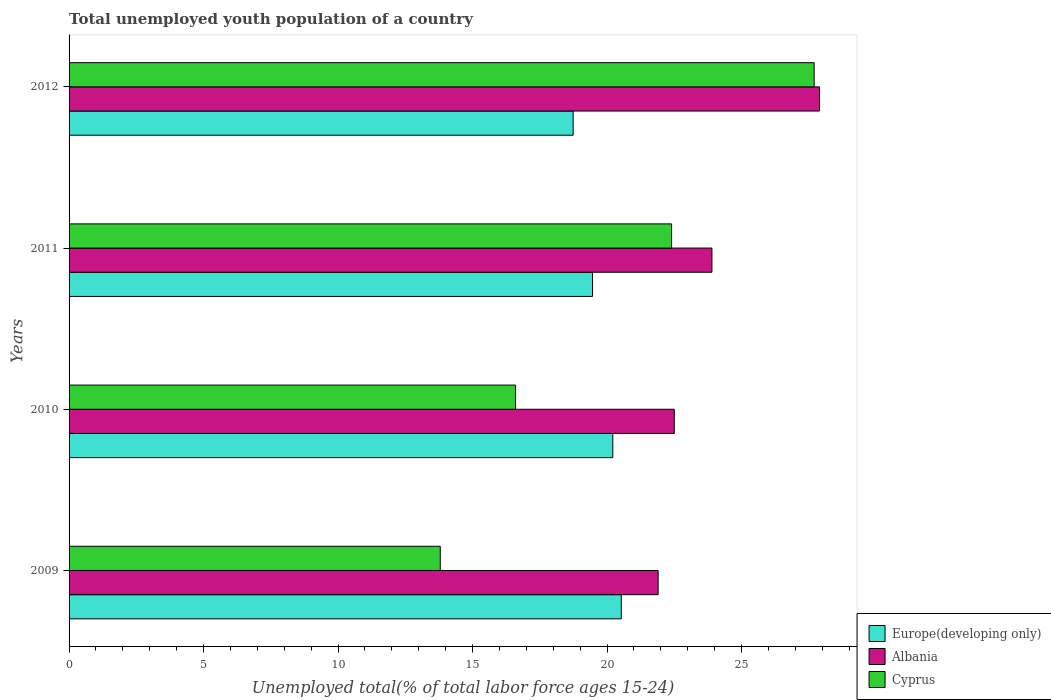How many different coloured bars are there?
Give a very brief answer. 3. How many groups of bars are there?
Your answer should be very brief. 4. How many bars are there on the 4th tick from the top?
Provide a short and direct response. 3. In how many cases, is the number of bars for a given year not equal to the number of legend labels?
Give a very brief answer. 0. What is the percentage of total unemployed youth population of a country in Cyprus in 2009?
Offer a terse response. 13.8. Across all years, what is the maximum percentage of total unemployed youth population of a country in Europe(developing only)?
Offer a very short reply. 20.53. Across all years, what is the minimum percentage of total unemployed youth population of a country in Cyprus?
Ensure brevity in your answer.  13.8. In which year was the percentage of total unemployed youth population of a country in Europe(developing only) maximum?
Provide a short and direct response. 2009. What is the total percentage of total unemployed youth population of a country in Europe(developing only) in the graph?
Provide a short and direct response. 78.95. What is the difference between the percentage of total unemployed youth population of a country in Albania in 2009 and that in 2010?
Your answer should be compact. -0.6. What is the difference between the percentage of total unemployed youth population of a country in Albania in 2010 and the percentage of total unemployed youth population of a country in Cyprus in 2009?
Offer a terse response. 8.7. What is the average percentage of total unemployed youth population of a country in Europe(developing only) per year?
Make the answer very short. 19.74. In the year 2009, what is the difference between the percentage of total unemployed youth population of a country in Albania and percentage of total unemployed youth population of a country in Europe(developing only)?
Offer a terse response. 1.37. What is the ratio of the percentage of total unemployed youth population of a country in Cyprus in 2010 to that in 2011?
Make the answer very short. 0.74. Is the percentage of total unemployed youth population of a country in Cyprus in 2009 less than that in 2011?
Your answer should be very brief. Yes. What is the difference between the highest and the second highest percentage of total unemployed youth population of a country in Cyprus?
Your response must be concise. 5.3. What is the difference between the highest and the lowest percentage of total unemployed youth population of a country in Europe(developing only)?
Your response must be concise. 1.79. Is the sum of the percentage of total unemployed youth population of a country in Albania in 2010 and 2012 greater than the maximum percentage of total unemployed youth population of a country in Cyprus across all years?
Give a very brief answer. Yes. What does the 1st bar from the top in 2012 represents?
Ensure brevity in your answer.  Cyprus. What does the 1st bar from the bottom in 2011 represents?
Offer a terse response. Europe(developing only). Is it the case that in every year, the sum of the percentage of total unemployed youth population of a country in Cyprus and percentage of total unemployed youth population of a country in Albania is greater than the percentage of total unemployed youth population of a country in Europe(developing only)?
Provide a short and direct response. Yes. How many bars are there?
Provide a succinct answer. 12. Are all the bars in the graph horizontal?
Offer a very short reply. Yes. How many years are there in the graph?
Your response must be concise. 4. What is the difference between two consecutive major ticks on the X-axis?
Provide a short and direct response. 5. Are the values on the major ticks of X-axis written in scientific E-notation?
Provide a short and direct response. No. Does the graph contain any zero values?
Ensure brevity in your answer.  No. Does the graph contain grids?
Make the answer very short. No. Where does the legend appear in the graph?
Offer a very short reply. Bottom right. How are the legend labels stacked?
Make the answer very short. Vertical. What is the title of the graph?
Give a very brief answer. Total unemployed youth population of a country. What is the label or title of the X-axis?
Give a very brief answer. Unemployed total(% of total labor force ages 15-24). What is the Unemployed total(% of total labor force ages 15-24) in Europe(developing only) in 2009?
Your answer should be very brief. 20.53. What is the Unemployed total(% of total labor force ages 15-24) in Albania in 2009?
Make the answer very short. 21.9. What is the Unemployed total(% of total labor force ages 15-24) in Cyprus in 2009?
Provide a short and direct response. 13.8. What is the Unemployed total(% of total labor force ages 15-24) in Europe(developing only) in 2010?
Provide a short and direct response. 20.21. What is the Unemployed total(% of total labor force ages 15-24) of Albania in 2010?
Provide a succinct answer. 22.5. What is the Unemployed total(% of total labor force ages 15-24) of Cyprus in 2010?
Offer a terse response. 16.6. What is the Unemployed total(% of total labor force ages 15-24) in Europe(developing only) in 2011?
Provide a succinct answer. 19.46. What is the Unemployed total(% of total labor force ages 15-24) in Albania in 2011?
Your answer should be very brief. 23.9. What is the Unemployed total(% of total labor force ages 15-24) of Cyprus in 2011?
Offer a terse response. 22.4. What is the Unemployed total(% of total labor force ages 15-24) of Europe(developing only) in 2012?
Provide a succinct answer. 18.74. What is the Unemployed total(% of total labor force ages 15-24) in Albania in 2012?
Provide a short and direct response. 27.9. What is the Unemployed total(% of total labor force ages 15-24) in Cyprus in 2012?
Ensure brevity in your answer.  27.7. Across all years, what is the maximum Unemployed total(% of total labor force ages 15-24) of Europe(developing only)?
Your answer should be very brief. 20.53. Across all years, what is the maximum Unemployed total(% of total labor force ages 15-24) of Albania?
Provide a succinct answer. 27.9. Across all years, what is the maximum Unemployed total(% of total labor force ages 15-24) of Cyprus?
Provide a short and direct response. 27.7. Across all years, what is the minimum Unemployed total(% of total labor force ages 15-24) in Europe(developing only)?
Make the answer very short. 18.74. Across all years, what is the minimum Unemployed total(% of total labor force ages 15-24) in Albania?
Provide a short and direct response. 21.9. Across all years, what is the minimum Unemployed total(% of total labor force ages 15-24) in Cyprus?
Keep it short and to the point. 13.8. What is the total Unemployed total(% of total labor force ages 15-24) of Europe(developing only) in the graph?
Provide a short and direct response. 78.95. What is the total Unemployed total(% of total labor force ages 15-24) of Albania in the graph?
Keep it short and to the point. 96.2. What is the total Unemployed total(% of total labor force ages 15-24) of Cyprus in the graph?
Provide a short and direct response. 80.5. What is the difference between the Unemployed total(% of total labor force ages 15-24) of Europe(developing only) in 2009 and that in 2010?
Make the answer very short. 0.31. What is the difference between the Unemployed total(% of total labor force ages 15-24) in Cyprus in 2009 and that in 2010?
Your response must be concise. -2.8. What is the difference between the Unemployed total(% of total labor force ages 15-24) in Europe(developing only) in 2009 and that in 2011?
Offer a terse response. 1.07. What is the difference between the Unemployed total(% of total labor force ages 15-24) in Europe(developing only) in 2009 and that in 2012?
Offer a very short reply. 1.79. What is the difference between the Unemployed total(% of total labor force ages 15-24) in Albania in 2009 and that in 2012?
Your response must be concise. -6. What is the difference between the Unemployed total(% of total labor force ages 15-24) of Europe(developing only) in 2010 and that in 2011?
Ensure brevity in your answer.  0.75. What is the difference between the Unemployed total(% of total labor force ages 15-24) of Albania in 2010 and that in 2011?
Offer a terse response. -1.4. What is the difference between the Unemployed total(% of total labor force ages 15-24) of Cyprus in 2010 and that in 2011?
Make the answer very short. -5.8. What is the difference between the Unemployed total(% of total labor force ages 15-24) in Europe(developing only) in 2010 and that in 2012?
Your answer should be very brief. 1.47. What is the difference between the Unemployed total(% of total labor force ages 15-24) in Cyprus in 2010 and that in 2012?
Provide a short and direct response. -11.1. What is the difference between the Unemployed total(% of total labor force ages 15-24) of Europe(developing only) in 2011 and that in 2012?
Your answer should be compact. 0.72. What is the difference between the Unemployed total(% of total labor force ages 15-24) in Europe(developing only) in 2009 and the Unemployed total(% of total labor force ages 15-24) in Albania in 2010?
Offer a very short reply. -1.97. What is the difference between the Unemployed total(% of total labor force ages 15-24) in Europe(developing only) in 2009 and the Unemployed total(% of total labor force ages 15-24) in Cyprus in 2010?
Provide a succinct answer. 3.93. What is the difference between the Unemployed total(% of total labor force ages 15-24) of Albania in 2009 and the Unemployed total(% of total labor force ages 15-24) of Cyprus in 2010?
Provide a succinct answer. 5.3. What is the difference between the Unemployed total(% of total labor force ages 15-24) in Europe(developing only) in 2009 and the Unemployed total(% of total labor force ages 15-24) in Albania in 2011?
Keep it short and to the point. -3.37. What is the difference between the Unemployed total(% of total labor force ages 15-24) in Europe(developing only) in 2009 and the Unemployed total(% of total labor force ages 15-24) in Cyprus in 2011?
Keep it short and to the point. -1.87. What is the difference between the Unemployed total(% of total labor force ages 15-24) of Albania in 2009 and the Unemployed total(% of total labor force ages 15-24) of Cyprus in 2011?
Offer a terse response. -0.5. What is the difference between the Unemployed total(% of total labor force ages 15-24) of Europe(developing only) in 2009 and the Unemployed total(% of total labor force ages 15-24) of Albania in 2012?
Keep it short and to the point. -7.37. What is the difference between the Unemployed total(% of total labor force ages 15-24) in Europe(developing only) in 2009 and the Unemployed total(% of total labor force ages 15-24) in Cyprus in 2012?
Give a very brief answer. -7.17. What is the difference between the Unemployed total(% of total labor force ages 15-24) of Albania in 2009 and the Unemployed total(% of total labor force ages 15-24) of Cyprus in 2012?
Make the answer very short. -5.8. What is the difference between the Unemployed total(% of total labor force ages 15-24) of Europe(developing only) in 2010 and the Unemployed total(% of total labor force ages 15-24) of Albania in 2011?
Offer a terse response. -3.69. What is the difference between the Unemployed total(% of total labor force ages 15-24) in Europe(developing only) in 2010 and the Unemployed total(% of total labor force ages 15-24) in Cyprus in 2011?
Your answer should be very brief. -2.19. What is the difference between the Unemployed total(% of total labor force ages 15-24) in Albania in 2010 and the Unemployed total(% of total labor force ages 15-24) in Cyprus in 2011?
Ensure brevity in your answer.  0.1. What is the difference between the Unemployed total(% of total labor force ages 15-24) of Europe(developing only) in 2010 and the Unemployed total(% of total labor force ages 15-24) of Albania in 2012?
Offer a very short reply. -7.69. What is the difference between the Unemployed total(% of total labor force ages 15-24) in Europe(developing only) in 2010 and the Unemployed total(% of total labor force ages 15-24) in Cyprus in 2012?
Your answer should be very brief. -7.49. What is the difference between the Unemployed total(% of total labor force ages 15-24) in Europe(developing only) in 2011 and the Unemployed total(% of total labor force ages 15-24) in Albania in 2012?
Your answer should be compact. -8.44. What is the difference between the Unemployed total(% of total labor force ages 15-24) of Europe(developing only) in 2011 and the Unemployed total(% of total labor force ages 15-24) of Cyprus in 2012?
Provide a short and direct response. -8.24. What is the average Unemployed total(% of total labor force ages 15-24) in Europe(developing only) per year?
Give a very brief answer. 19.74. What is the average Unemployed total(% of total labor force ages 15-24) of Albania per year?
Your answer should be compact. 24.05. What is the average Unemployed total(% of total labor force ages 15-24) of Cyprus per year?
Your answer should be compact. 20.12. In the year 2009, what is the difference between the Unemployed total(% of total labor force ages 15-24) of Europe(developing only) and Unemployed total(% of total labor force ages 15-24) of Albania?
Your response must be concise. -1.37. In the year 2009, what is the difference between the Unemployed total(% of total labor force ages 15-24) in Europe(developing only) and Unemployed total(% of total labor force ages 15-24) in Cyprus?
Your answer should be very brief. 6.73. In the year 2009, what is the difference between the Unemployed total(% of total labor force ages 15-24) of Albania and Unemployed total(% of total labor force ages 15-24) of Cyprus?
Provide a short and direct response. 8.1. In the year 2010, what is the difference between the Unemployed total(% of total labor force ages 15-24) in Europe(developing only) and Unemployed total(% of total labor force ages 15-24) in Albania?
Offer a very short reply. -2.29. In the year 2010, what is the difference between the Unemployed total(% of total labor force ages 15-24) of Europe(developing only) and Unemployed total(% of total labor force ages 15-24) of Cyprus?
Provide a succinct answer. 3.61. In the year 2011, what is the difference between the Unemployed total(% of total labor force ages 15-24) of Europe(developing only) and Unemployed total(% of total labor force ages 15-24) of Albania?
Your answer should be very brief. -4.44. In the year 2011, what is the difference between the Unemployed total(% of total labor force ages 15-24) in Europe(developing only) and Unemployed total(% of total labor force ages 15-24) in Cyprus?
Offer a terse response. -2.94. In the year 2012, what is the difference between the Unemployed total(% of total labor force ages 15-24) in Europe(developing only) and Unemployed total(% of total labor force ages 15-24) in Albania?
Offer a terse response. -9.16. In the year 2012, what is the difference between the Unemployed total(% of total labor force ages 15-24) of Europe(developing only) and Unemployed total(% of total labor force ages 15-24) of Cyprus?
Offer a very short reply. -8.96. What is the ratio of the Unemployed total(% of total labor force ages 15-24) in Europe(developing only) in 2009 to that in 2010?
Keep it short and to the point. 1.02. What is the ratio of the Unemployed total(% of total labor force ages 15-24) in Albania in 2009 to that in 2010?
Make the answer very short. 0.97. What is the ratio of the Unemployed total(% of total labor force ages 15-24) of Cyprus in 2009 to that in 2010?
Provide a short and direct response. 0.83. What is the ratio of the Unemployed total(% of total labor force ages 15-24) in Europe(developing only) in 2009 to that in 2011?
Give a very brief answer. 1.05. What is the ratio of the Unemployed total(% of total labor force ages 15-24) of Albania in 2009 to that in 2011?
Your response must be concise. 0.92. What is the ratio of the Unemployed total(% of total labor force ages 15-24) in Cyprus in 2009 to that in 2011?
Provide a short and direct response. 0.62. What is the ratio of the Unemployed total(% of total labor force ages 15-24) of Europe(developing only) in 2009 to that in 2012?
Your response must be concise. 1.1. What is the ratio of the Unemployed total(% of total labor force ages 15-24) in Albania in 2009 to that in 2012?
Ensure brevity in your answer.  0.78. What is the ratio of the Unemployed total(% of total labor force ages 15-24) of Cyprus in 2009 to that in 2012?
Provide a short and direct response. 0.5. What is the ratio of the Unemployed total(% of total labor force ages 15-24) in Europe(developing only) in 2010 to that in 2011?
Your answer should be very brief. 1.04. What is the ratio of the Unemployed total(% of total labor force ages 15-24) in Albania in 2010 to that in 2011?
Offer a terse response. 0.94. What is the ratio of the Unemployed total(% of total labor force ages 15-24) in Cyprus in 2010 to that in 2011?
Ensure brevity in your answer.  0.74. What is the ratio of the Unemployed total(% of total labor force ages 15-24) in Europe(developing only) in 2010 to that in 2012?
Keep it short and to the point. 1.08. What is the ratio of the Unemployed total(% of total labor force ages 15-24) of Albania in 2010 to that in 2012?
Ensure brevity in your answer.  0.81. What is the ratio of the Unemployed total(% of total labor force ages 15-24) of Cyprus in 2010 to that in 2012?
Make the answer very short. 0.6. What is the ratio of the Unemployed total(% of total labor force ages 15-24) of Europe(developing only) in 2011 to that in 2012?
Provide a short and direct response. 1.04. What is the ratio of the Unemployed total(% of total labor force ages 15-24) in Albania in 2011 to that in 2012?
Give a very brief answer. 0.86. What is the ratio of the Unemployed total(% of total labor force ages 15-24) of Cyprus in 2011 to that in 2012?
Your answer should be compact. 0.81. What is the difference between the highest and the second highest Unemployed total(% of total labor force ages 15-24) in Europe(developing only)?
Provide a short and direct response. 0.31. What is the difference between the highest and the second highest Unemployed total(% of total labor force ages 15-24) in Cyprus?
Provide a succinct answer. 5.3. What is the difference between the highest and the lowest Unemployed total(% of total labor force ages 15-24) in Europe(developing only)?
Offer a terse response. 1.79. What is the difference between the highest and the lowest Unemployed total(% of total labor force ages 15-24) of Albania?
Your answer should be very brief. 6. What is the difference between the highest and the lowest Unemployed total(% of total labor force ages 15-24) of Cyprus?
Make the answer very short. 13.9. 